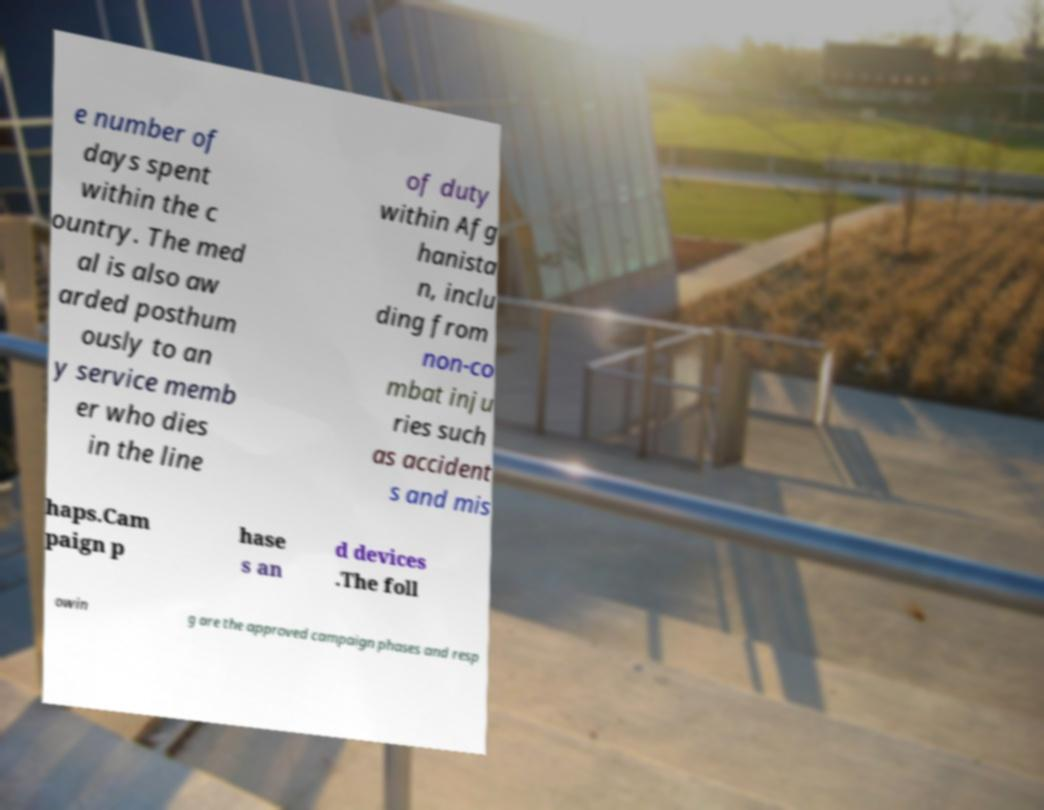Could you assist in decoding the text presented in this image and type it out clearly? e number of days spent within the c ountry. The med al is also aw arded posthum ously to an y service memb er who dies in the line of duty within Afg hanista n, inclu ding from non-co mbat inju ries such as accident s and mis haps.Cam paign p hase s an d devices .The foll owin g are the approved campaign phases and resp 